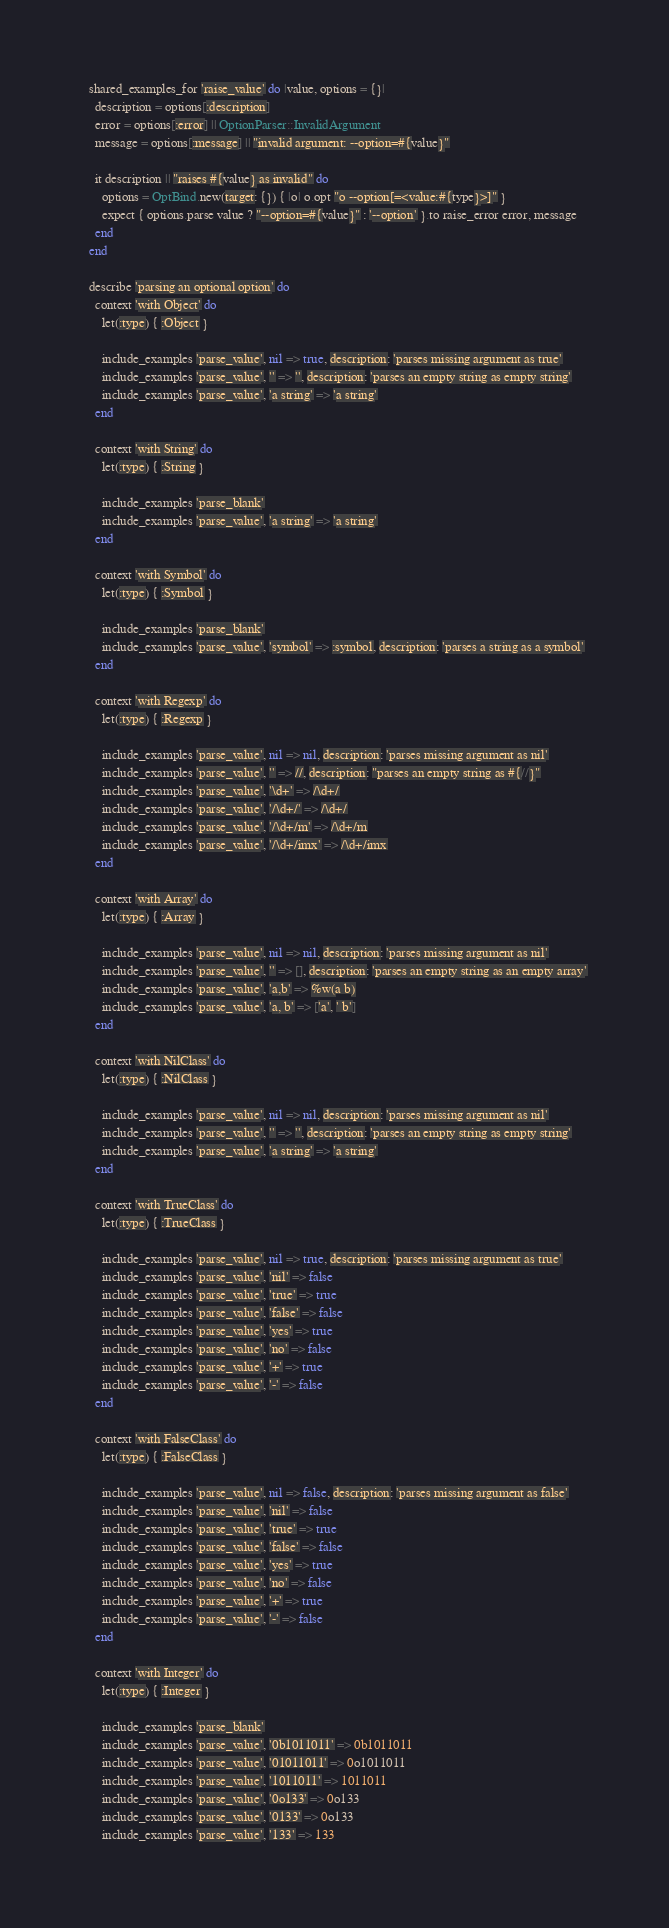<code> <loc_0><loc_0><loc_500><loc_500><_Ruby_>  shared_examples_for 'raise_value' do |value, options = {}|
    description = options[:description]
    error = options[:error] || OptionParser::InvalidArgument
    message = options[:message] || "invalid argument: --option=#{value}"

    it description || "raises #{value} as invalid" do
      options = OptBind.new(target: {}) { |o| o.opt "o --option[=<value:#{type}>]" }
      expect { options.parse value ? "--option=#{value}" : '--option' }.to raise_error error, message
    end
  end

  describe 'parsing an optional option' do
    context 'with Object' do
      let(:type) { :Object }

      include_examples 'parse_value', nil => true, description: 'parses missing argument as true'
      include_examples 'parse_value', '' => '', description: 'parses an empty string as empty string'
      include_examples 'parse_value', 'a string' => 'a string'
    end

    context 'with String' do
      let(:type) { :String }

      include_examples 'parse_blank'
      include_examples 'parse_value', 'a string' => 'a string'
    end

    context 'with Symbol' do
      let(:type) { :Symbol }

      include_examples 'parse_blank'
      include_examples 'parse_value', 'symbol' => :symbol, description: 'parses a string as a symbol'
    end

    context 'with Regexp' do
      let(:type) { :Regexp }

      include_examples 'parse_value', nil => nil, description: 'parses missing argument as nil'
      include_examples 'parse_value', '' => //, description: "parses an empty string as #{//}"
      include_examples 'parse_value', '\d+' => /\d+/
      include_examples 'parse_value', '/\d+/' => /\d+/
      include_examples 'parse_value', '/\d+/m' => /\d+/m
      include_examples 'parse_value', '/\d+/imx' => /\d+/imx
    end

    context 'with Array' do
      let(:type) { :Array }

      include_examples 'parse_value', nil => nil, description: 'parses missing argument as nil'
      include_examples 'parse_value', '' => [], description: 'parses an empty string as an empty array'
      include_examples 'parse_value', 'a,b' => %w(a b)
      include_examples 'parse_value', 'a, b' => ['a', ' b']
    end

    context 'with NilClass' do
      let(:type) { :NilClass }

      include_examples 'parse_value', nil => nil, description: 'parses missing argument as nil'
      include_examples 'parse_value', '' => '', description: 'parses an empty string as empty string'
      include_examples 'parse_value', 'a string' => 'a string'
    end

    context 'with TrueClass' do
      let(:type) { :TrueClass }

      include_examples 'parse_value', nil => true, description: 'parses missing argument as true'
      include_examples 'parse_value', 'nil' => false
      include_examples 'parse_value', 'true' => true
      include_examples 'parse_value', 'false' => false
      include_examples 'parse_value', 'yes' => true
      include_examples 'parse_value', 'no' => false
      include_examples 'parse_value', '+' => true
      include_examples 'parse_value', '-' => false
    end

    context 'with FalseClass' do
      let(:type) { :FalseClass }

      include_examples 'parse_value', nil => false, description: 'parses missing argument as false'
      include_examples 'parse_value', 'nil' => false
      include_examples 'parse_value', 'true' => true
      include_examples 'parse_value', 'false' => false
      include_examples 'parse_value', 'yes' => true
      include_examples 'parse_value', 'no' => false
      include_examples 'parse_value', '+' => true
      include_examples 'parse_value', '-' => false
    end

    context 'with Integer' do
      let(:type) { :Integer }

      include_examples 'parse_blank'
      include_examples 'parse_value', '0b1011011' => 0b1011011
      include_examples 'parse_value', '01011011' => 0o1011011
      include_examples 'parse_value', '1011011' => 1011011
      include_examples 'parse_value', '0o133' => 0o133
      include_examples 'parse_value', '0133' => 0o133
      include_examples 'parse_value', '133' => 133</code> 